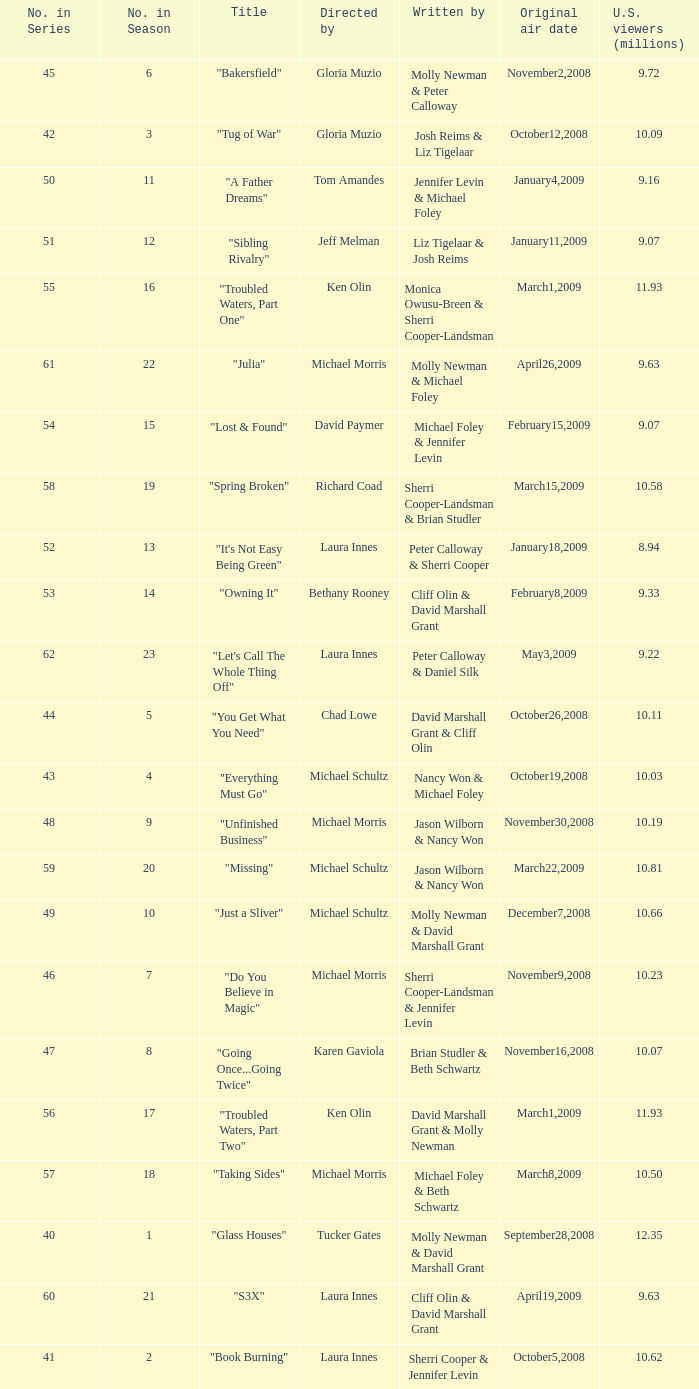When did the episode titled "Do you believe in magic" run for the first time? November9,2008. 